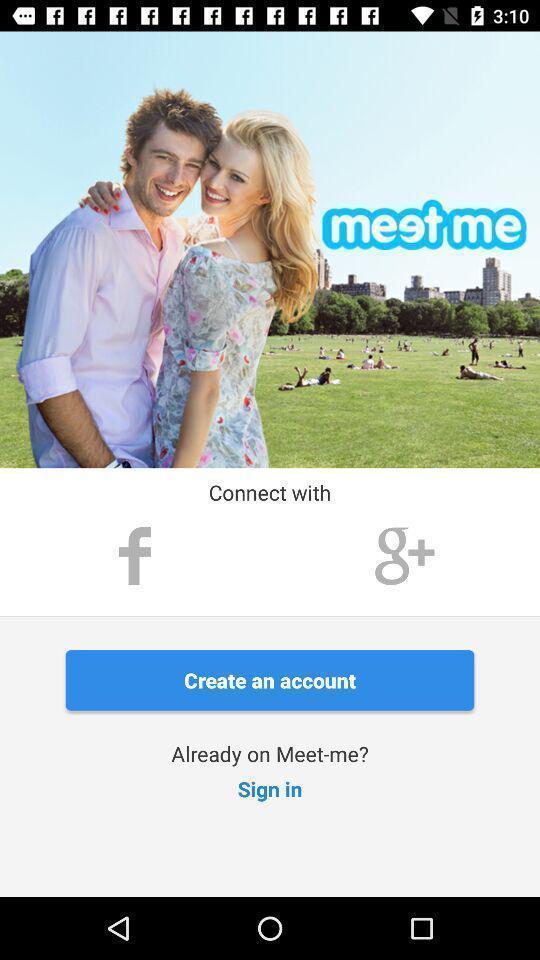Give me a narrative description of this picture. Welcome page for a social network app. 